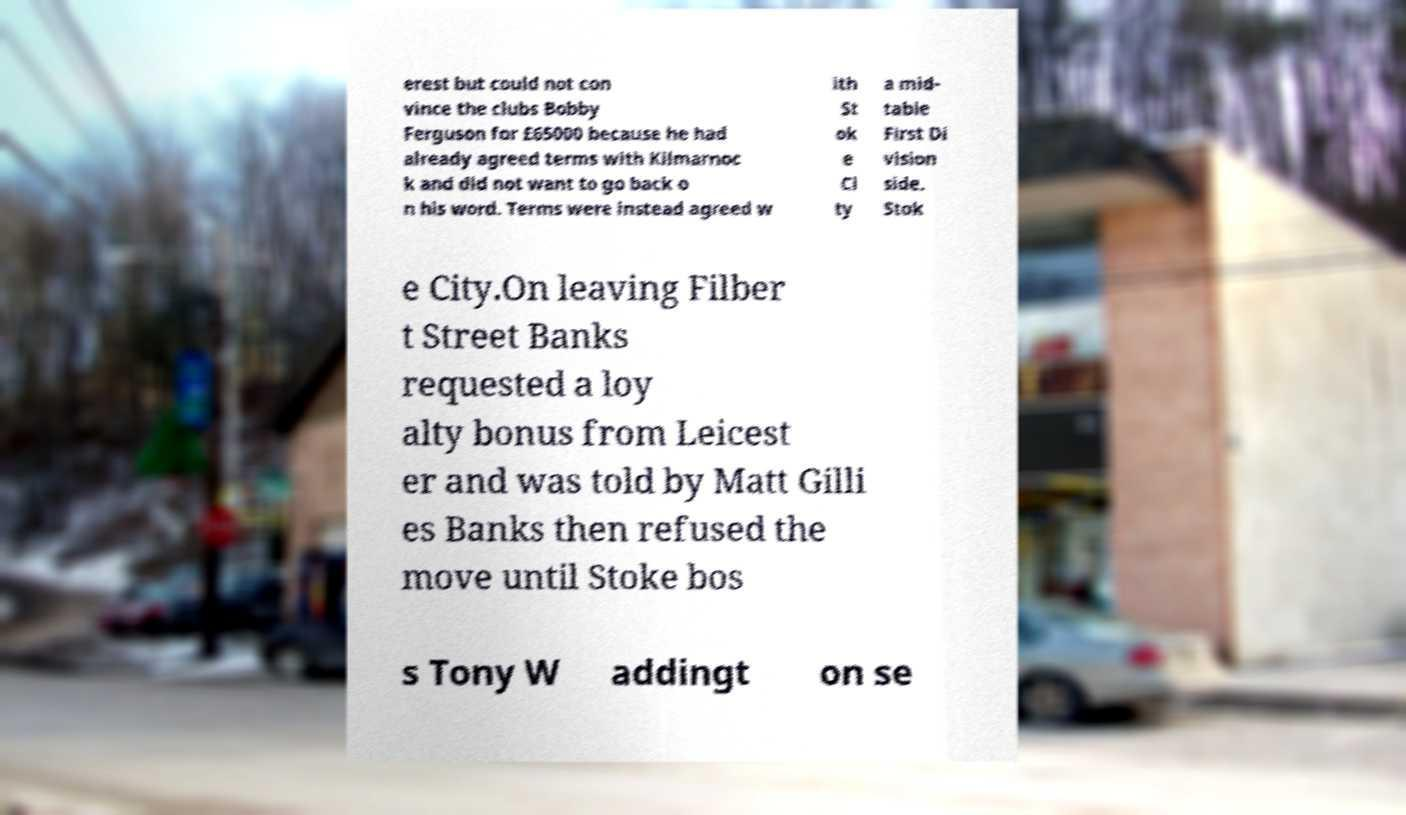Could you extract and type out the text from this image? erest but could not con vince the clubs Bobby Ferguson for £65000 because he had already agreed terms with Kilmarnoc k and did not want to go back o n his word. Terms were instead agreed w ith St ok e Ci ty a mid- table First Di vision side. Stok e City.On leaving Filber t Street Banks requested a loy alty bonus from Leicest er and was told by Matt Gilli es Banks then refused the move until Stoke bos s Tony W addingt on se 